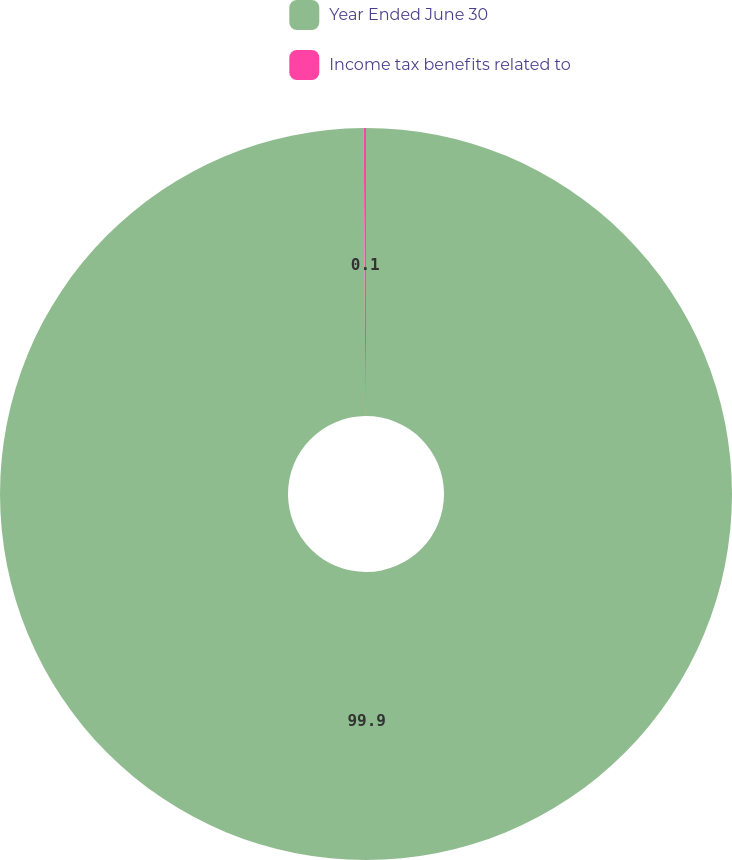<chart> <loc_0><loc_0><loc_500><loc_500><pie_chart><fcel>Year Ended June 30<fcel>Income tax benefits related to<nl><fcel>99.9%<fcel>0.1%<nl></chart> 